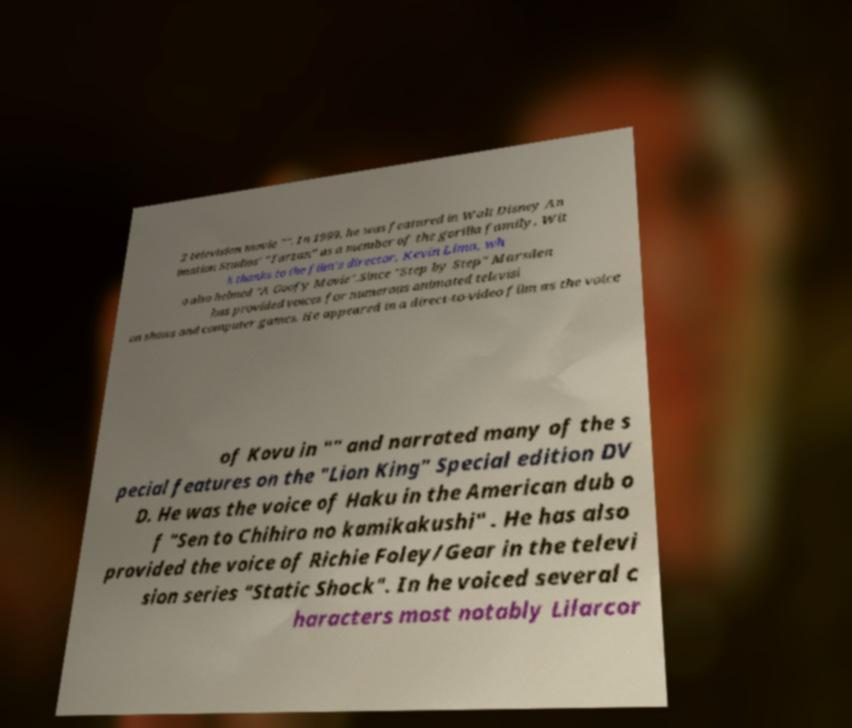For documentation purposes, I need the text within this image transcribed. Could you provide that? 2 television movie "". In 1999, he was featured in Walt Disney An imation Studios' "Tarzan" as a member of the gorilla family. Wit h thanks to the film's director, Kevin Lima, wh o also helmed "A Goofy Movie".Since "Step by Step" Marsden has provided voices for numerous animated televisi on shows and computer games. He appeared in a direct-to-video film as the voice of Kovu in "" and narrated many of the s pecial features on the "Lion King" Special edition DV D. He was the voice of Haku in the American dub o f "Sen to Chihiro no kamikakushi" . He has also provided the voice of Richie Foley/Gear in the televi sion series "Static Shock". In he voiced several c haracters most notably Lilarcor 